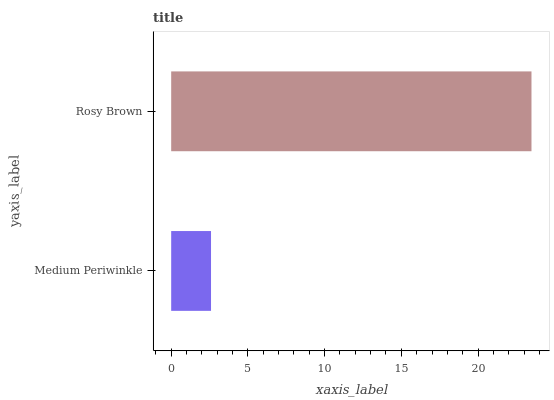Is Medium Periwinkle the minimum?
Answer yes or no. Yes. Is Rosy Brown the maximum?
Answer yes or no. Yes. Is Rosy Brown the minimum?
Answer yes or no. No. Is Rosy Brown greater than Medium Periwinkle?
Answer yes or no. Yes. Is Medium Periwinkle less than Rosy Brown?
Answer yes or no. Yes. Is Medium Periwinkle greater than Rosy Brown?
Answer yes or no. No. Is Rosy Brown less than Medium Periwinkle?
Answer yes or no. No. Is Rosy Brown the high median?
Answer yes or no. Yes. Is Medium Periwinkle the low median?
Answer yes or no. Yes. Is Medium Periwinkle the high median?
Answer yes or no. No. Is Rosy Brown the low median?
Answer yes or no. No. 